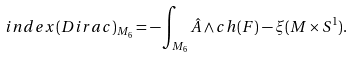<formula> <loc_0><loc_0><loc_500><loc_500>i n d e x ( D i r a c ) _ { M _ { 6 } } = - \int _ { M _ { 6 } } \hat { A } \wedge c h ( F ) - \xi ( M \times S ^ { 1 } ) .</formula> 